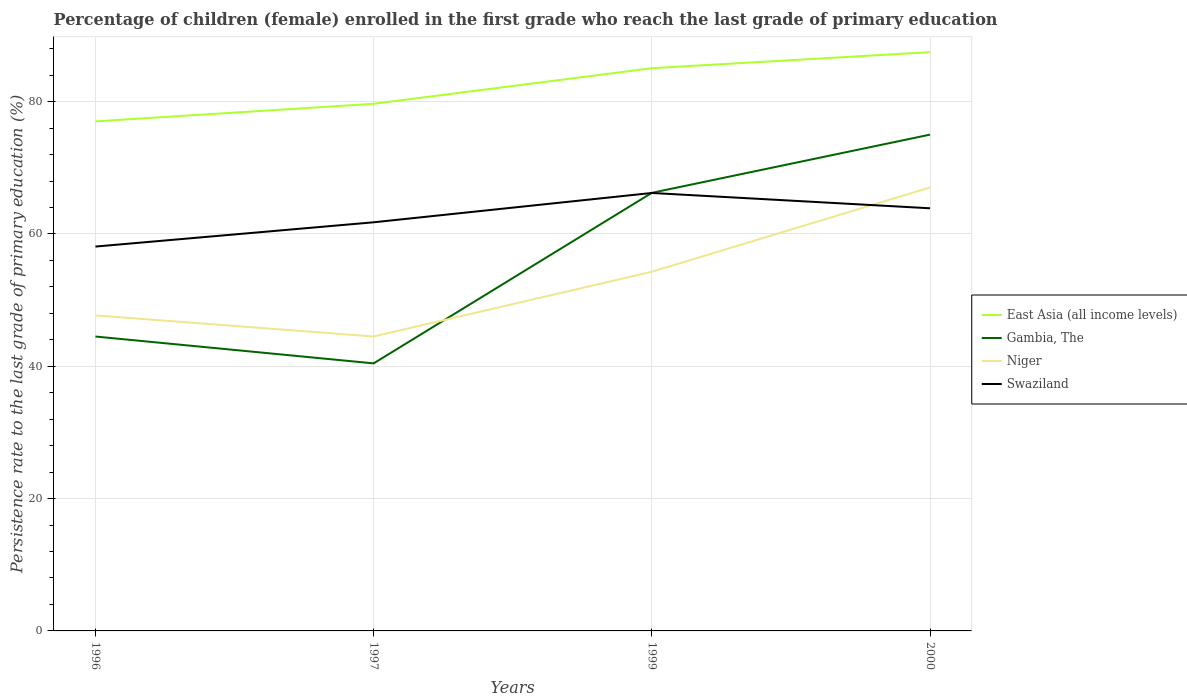Across all years, what is the maximum persistence rate of children in Niger?
Make the answer very short. 44.51. What is the total persistence rate of children in East Asia (all income levels) in the graph?
Offer a very short reply. -8.04. What is the difference between the highest and the second highest persistence rate of children in Gambia, The?
Your answer should be very brief. 34.57. What is the difference between the highest and the lowest persistence rate of children in Niger?
Provide a short and direct response. 2. Are the values on the major ticks of Y-axis written in scientific E-notation?
Give a very brief answer. No. Does the graph contain any zero values?
Your answer should be compact. No. How many legend labels are there?
Keep it short and to the point. 4. How are the legend labels stacked?
Give a very brief answer. Vertical. What is the title of the graph?
Your answer should be very brief. Percentage of children (female) enrolled in the first grade who reach the last grade of primary education. What is the label or title of the Y-axis?
Offer a very short reply. Persistence rate to the last grade of primary education (%). What is the Persistence rate to the last grade of primary education (%) in East Asia (all income levels) in 1996?
Your answer should be compact. 77.02. What is the Persistence rate to the last grade of primary education (%) of Gambia, The in 1996?
Your answer should be very brief. 44.5. What is the Persistence rate to the last grade of primary education (%) of Niger in 1996?
Your response must be concise. 47.69. What is the Persistence rate to the last grade of primary education (%) in Swaziland in 1996?
Keep it short and to the point. 58.1. What is the Persistence rate to the last grade of primary education (%) of East Asia (all income levels) in 1997?
Provide a succinct answer. 79.68. What is the Persistence rate to the last grade of primary education (%) of Gambia, The in 1997?
Offer a very short reply. 40.44. What is the Persistence rate to the last grade of primary education (%) in Niger in 1997?
Your response must be concise. 44.51. What is the Persistence rate to the last grade of primary education (%) of Swaziland in 1997?
Your response must be concise. 61.77. What is the Persistence rate to the last grade of primary education (%) in East Asia (all income levels) in 1999?
Your response must be concise. 85.05. What is the Persistence rate to the last grade of primary education (%) in Gambia, The in 1999?
Your answer should be very brief. 66.22. What is the Persistence rate to the last grade of primary education (%) of Niger in 1999?
Your answer should be compact. 54.29. What is the Persistence rate to the last grade of primary education (%) of Swaziland in 1999?
Provide a succinct answer. 66.2. What is the Persistence rate to the last grade of primary education (%) of East Asia (all income levels) in 2000?
Provide a short and direct response. 87.48. What is the Persistence rate to the last grade of primary education (%) of Gambia, The in 2000?
Offer a very short reply. 75.01. What is the Persistence rate to the last grade of primary education (%) in Niger in 2000?
Your answer should be very brief. 67.03. What is the Persistence rate to the last grade of primary education (%) in Swaziland in 2000?
Your answer should be very brief. 63.88. Across all years, what is the maximum Persistence rate to the last grade of primary education (%) in East Asia (all income levels)?
Your answer should be compact. 87.48. Across all years, what is the maximum Persistence rate to the last grade of primary education (%) in Gambia, The?
Keep it short and to the point. 75.01. Across all years, what is the maximum Persistence rate to the last grade of primary education (%) of Niger?
Your answer should be very brief. 67.03. Across all years, what is the maximum Persistence rate to the last grade of primary education (%) of Swaziland?
Provide a succinct answer. 66.2. Across all years, what is the minimum Persistence rate to the last grade of primary education (%) in East Asia (all income levels)?
Your answer should be compact. 77.02. Across all years, what is the minimum Persistence rate to the last grade of primary education (%) in Gambia, The?
Ensure brevity in your answer.  40.44. Across all years, what is the minimum Persistence rate to the last grade of primary education (%) of Niger?
Offer a very short reply. 44.51. Across all years, what is the minimum Persistence rate to the last grade of primary education (%) in Swaziland?
Ensure brevity in your answer.  58.1. What is the total Persistence rate to the last grade of primary education (%) of East Asia (all income levels) in the graph?
Provide a short and direct response. 329.23. What is the total Persistence rate to the last grade of primary education (%) in Gambia, The in the graph?
Make the answer very short. 226.17. What is the total Persistence rate to the last grade of primary education (%) of Niger in the graph?
Offer a very short reply. 213.52. What is the total Persistence rate to the last grade of primary education (%) in Swaziland in the graph?
Offer a terse response. 249.94. What is the difference between the Persistence rate to the last grade of primary education (%) of East Asia (all income levels) in 1996 and that in 1997?
Provide a succinct answer. -2.66. What is the difference between the Persistence rate to the last grade of primary education (%) of Gambia, The in 1996 and that in 1997?
Your answer should be compact. 4.06. What is the difference between the Persistence rate to the last grade of primary education (%) in Niger in 1996 and that in 1997?
Give a very brief answer. 3.19. What is the difference between the Persistence rate to the last grade of primary education (%) of Swaziland in 1996 and that in 1997?
Offer a terse response. -3.67. What is the difference between the Persistence rate to the last grade of primary education (%) in East Asia (all income levels) in 1996 and that in 1999?
Your response must be concise. -8.04. What is the difference between the Persistence rate to the last grade of primary education (%) of Gambia, The in 1996 and that in 1999?
Give a very brief answer. -21.72. What is the difference between the Persistence rate to the last grade of primary education (%) of Niger in 1996 and that in 1999?
Make the answer very short. -6.6. What is the difference between the Persistence rate to the last grade of primary education (%) of Swaziland in 1996 and that in 1999?
Your answer should be very brief. -8.1. What is the difference between the Persistence rate to the last grade of primary education (%) of East Asia (all income levels) in 1996 and that in 2000?
Offer a very short reply. -10.47. What is the difference between the Persistence rate to the last grade of primary education (%) in Gambia, The in 1996 and that in 2000?
Your response must be concise. -30.52. What is the difference between the Persistence rate to the last grade of primary education (%) in Niger in 1996 and that in 2000?
Provide a short and direct response. -19.34. What is the difference between the Persistence rate to the last grade of primary education (%) in Swaziland in 1996 and that in 2000?
Ensure brevity in your answer.  -5.79. What is the difference between the Persistence rate to the last grade of primary education (%) in East Asia (all income levels) in 1997 and that in 1999?
Make the answer very short. -5.38. What is the difference between the Persistence rate to the last grade of primary education (%) of Gambia, The in 1997 and that in 1999?
Give a very brief answer. -25.78. What is the difference between the Persistence rate to the last grade of primary education (%) of Niger in 1997 and that in 1999?
Your response must be concise. -9.79. What is the difference between the Persistence rate to the last grade of primary education (%) of Swaziland in 1997 and that in 1999?
Make the answer very short. -4.43. What is the difference between the Persistence rate to the last grade of primary education (%) in East Asia (all income levels) in 1997 and that in 2000?
Your response must be concise. -7.81. What is the difference between the Persistence rate to the last grade of primary education (%) of Gambia, The in 1997 and that in 2000?
Keep it short and to the point. -34.57. What is the difference between the Persistence rate to the last grade of primary education (%) of Niger in 1997 and that in 2000?
Keep it short and to the point. -22.53. What is the difference between the Persistence rate to the last grade of primary education (%) of Swaziland in 1997 and that in 2000?
Give a very brief answer. -2.12. What is the difference between the Persistence rate to the last grade of primary education (%) in East Asia (all income levels) in 1999 and that in 2000?
Give a very brief answer. -2.43. What is the difference between the Persistence rate to the last grade of primary education (%) of Gambia, The in 1999 and that in 2000?
Offer a terse response. -8.8. What is the difference between the Persistence rate to the last grade of primary education (%) in Niger in 1999 and that in 2000?
Your answer should be compact. -12.74. What is the difference between the Persistence rate to the last grade of primary education (%) in Swaziland in 1999 and that in 2000?
Offer a terse response. 2.31. What is the difference between the Persistence rate to the last grade of primary education (%) of East Asia (all income levels) in 1996 and the Persistence rate to the last grade of primary education (%) of Gambia, The in 1997?
Provide a short and direct response. 36.58. What is the difference between the Persistence rate to the last grade of primary education (%) in East Asia (all income levels) in 1996 and the Persistence rate to the last grade of primary education (%) in Niger in 1997?
Provide a short and direct response. 32.51. What is the difference between the Persistence rate to the last grade of primary education (%) of East Asia (all income levels) in 1996 and the Persistence rate to the last grade of primary education (%) of Swaziland in 1997?
Your answer should be compact. 15.25. What is the difference between the Persistence rate to the last grade of primary education (%) of Gambia, The in 1996 and the Persistence rate to the last grade of primary education (%) of Niger in 1997?
Offer a terse response. -0.01. What is the difference between the Persistence rate to the last grade of primary education (%) of Gambia, The in 1996 and the Persistence rate to the last grade of primary education (%) of Swaziland in 1997?
Make the answer very short. -17.27. What is the difference between the Persistence rate to the last grade of primary education (%) in Niger in 1996 and the Persistence rate to the last grade of primary education (%) in Swaziland in 1997?
Make the answer very short. -14.07. What is the difference between the Persistence rate to the last grade of primary education (%) in East Asia (all income levels) in 1996 and the Persistence rate to the last grade of primary education (%) in Gambia, The in 1999?
Keep it short and to the point. 10.8. What is the difference between the Persistence rate to the last grade of primary education (%) of East Asia (all income levels) in 1996 and the Persistence rate to the last grade of primary education (%) of Niger in 1999?
Ensure brevity in your answer.  22.73. What is the difference between the Persistence rate to the last grade of primary education (%) of East Asia (all income levels) in 1996 and the Persistence rate to the last grade of primary education (%) of Swaziland in 1999?
Provide a short and direct response. 10.82. What is the difference between the Persistence rate to the last grade of primary education (%) of Gambia, The in 1996 and the Persistence rate to the last grade of primary education (%) of Niger in 1999?
Provide a short and direct response. -9.79. What is the difference between the Persistence rate to the last grade of primary education (%) in Gambia, The in 1996 and the Persistence rate to the last grade of primary education (%) in Swaziland in 1999?
Your response must be concise. -21.7. What is the difference between the Persistence rate to the last grade of primary education (%) of Niger in 1996 and the Persistence rate to the last grade of primary education (%) of Swaziland in 1999?
Your response must be concise. -18.51. What is the difference between the Persistence rate to the last grade of primary education (%) of East Asia (all income levels) in 1996 and the Persistence rate to the last grade of primary education (%) of Gambia, The in 2000?
Your response must be concise. 2. What is the difference between the Persistence rate to the last grade of primary education (%) of East Asia (all income levels) in 1996 and the Persistence rate to the last grade of primary education (%) of Niger in 2000?
Offer a terse response. 9.98. What is the difference between the Persistence rate to the last grade of primary education (%) of East Asia (all income levels) in 1996 and the Persistence rate to the last grade of primary education (%) of Swaziland in 2000?
Keep it short and to the point. 13.14. What is the difference between the Persistence rate to the last grade of primary education (%) in Gambia, The in 1996 and the Persistence rate to the last grade of primary education (%) in Niger in 2000?
Offer a terse response. -22.53. What is the difference between the Persistence rate to the last grade of primary education (%) in Gambia, The in 1996 and the Persistence rate to the last grade of primary education (%) in Swaziland in 2000?
Give a very brief answer. -19.38. What is the difference between the Persistence rate to the last grade of primary education (%) of Niger in 1996 and the Persistence rate to the last grade of primary education (%) of Swaziland in 2000?
Offer a terse response. -16.19. What is the difference between the Persistence rate to the last grade of primary education (%) in East Asia (all income levels) in 1997 and the Persistence rate to the last grade of primary education (%) in Gambia, The in 1999?
Give a very brief answer. 13.46. What is the difference between the Persistence rate to the last grade of primary education (%) in East Asia (all income levels) in 1997 and the Persistence rate to the last grade of primary education (%) in Niger in 1999?
Your answer should be compact. 25.38. What is the difference between the Persistence rate to the last grade of primary education (%) of East Asia (all income levels) in 1997 and the Persistence rate to the last grade of primary education (%) of Swaziland in 1999?
Provide a short and direct response. 13.48. What is the difference between the Persistence rate to the last grade of primary education (%) in Gambia, The in 1997 and the Persistence rate to the last grade of primary education (%) in Niger in 1999?
Give a very brief answer. -13.85. What is the difference between the Persistence rate to the last grade of primary education (%) in Gambia, The in 1997 and the Persistence rate to the last grade of primary education (%) in Swaziland in 1999?
Give a very brief answer. -25.76. What is the difference between the Persistence rate to the last grade of primary education (%) of Niger in 1997 and the Persistence rate to the last grade of primary education (%) of Swaziland in 1999?
Keep it short and to the point. -21.69. What is the difference between the Persistence rate to the last grade of primary education (%) of East Asia (all income levels) in 1997 and the Persistence rate to the last grade of primary education (%) of Gambia, The in 2000?
Provide a succinct answer. 4.66. What is the difference between the Persistence rate to the last grade of primary education (%) in East Asia (all income levels) in 1997 and the Persistence rate to the last grade of primary education (%) in Niger in 2000?
Offer a terse response. 12.64. What is the difference between the Persistence rate to the last grade of primary education (%) in East Asia (all income levels) in 1997 and the Persistence rate to the last grade of primary education (%) in Swaziland in 2000?
Your answer should be very brief. 15.79. What is the difference between the Persistence rate to the last grade of primary education (%) of Gambia, The in 1997 and the Persistence rate to the last grade of primary education (%) of Niger in 2000?
Provide a succinct answer. -26.59. What is the difference between the Persistence rate to the last grade of primary education (%) in Gambia, The in 1997 and the Persistence rate to the last grade of primary education (%) in Swaziland in 2000?
Make the answer very short. -23.44. What is the difference between the Persistence rate to the last grade of primary education (%) of Niger in 1997 and the Persistence rate to the last grade of primary education (%) of Swaziland in 2000?
Provide a succinct answer. -19.38. What is the difference between the Persistence rate to the last grade of primary education (%) of East Asia (all income levels) in 1999 and the Persistence rate to the last grade of primary education (%) of Gambia, The in 2000?
Keep it short and to the point. 10.04. What is the difference between the Persistence rate to the last grade of primary education (%) of East Asia (all income levels) in 1999 and the Persistence rate to the last grade of primary education (%) of Niger in 2000?
Offer a terse response. 18.02. What is the difference between the Persistence rate to the last grade of primary education (%) of East Asia (all income levels) in 1999 and the Persistence rate to the last grade of primary education (%) of Swaziland in 2000?
Your response must be concise. 21.17. What is the difference between the Persistence rate to the last grade of primary education (%) of Gambia, The in 1999 and the Persistence rate to the last grade of primary education (%) of Niger in 2000?
Offer a terse response. -0.81. What is the difference between the Persistence rate to the last grade of primary education (%) in Gambia, The in 1999 and the Persistence rate to the last grade of primary education (%) in Swaziland in 2000?
Offer a very short reply. 2.34. What is the difference between the Persistence rate to the last grade of primary education (%) in Niger in 1999 and the Persistence rate to the last grade of primary education (%) in Swaziland in 2000?
Provide a succinct answer. -9.59. What is the average Persistence rate to the last grade of primary education (%) in East Asia (all income levels) per year?
Give a very brief answer. 82.31. What is the average Persistence rate to the last grade of primary education (%) of Gambia, The per year?
Offer a very short reply. 56.54. What is the average Persistence rate to the last grade of primary education (%) of Niger per year?
Your answer should be very brief. 53.38. What is the average Persistence rate to the last grade of primary education (%) in Swaziland per year?
Offer a very short reply. 62.48. In the year 1996, what is the difference between the Persistence rate to the last grade of primary education (%) of East Asia (all income levels) and Persistence rate to the last grade of primary education (%) of Gambia, The?
Provide a short and direct response. 32.52. In the year 1996, what is the difference between the Persistence rate to the last grade of primary education (%) of East Asia (all income levels) and Persistence rate to the last grade of primary education (%) of Niger?
Ensure brevity in your answer.  29.33. In the year 1996, what is the difference between the Persistence rate to the last grade of primary education (%) in East Asia (all income levels) and Persistence rate to the last grade of primary education (%) in Swaziland?
Offer a terse response. 18.92. In the year 1996, what is the difference between the Persistence rate to the last grade of primary education (%) of Gambia, The and Persistence rate to the last grade of primary education (%) of Niger?
Provide a succinct answer. -3.19. In the year 1996, what is the difference between the Persistence rate to the last grade of primary education (%) in Gambia, The and Persistence rate to the last grade of primary education (%) in Swaziland?
Offer a very short reply. -13.6. In the year 1996, what is the difference between the Persistence rate to the last grade of primary education (%) of Niger and Persistence rate to the last grade of primary education (%) of Swaziland?
Give a very brief answer. -10.41. In the year 1997, what is the difference between the Persistence rate to the last grade of primary education (%) in East Asia (all income levels) and Persistence rate to the last grade of primary education (%) in Gambia, The?
Ensure brevity in your answer.  39.24. In the year 1997, what is the difference between the Persistence rate to the last grade of primary education (%) in East Asia (all income levels) and Persistence rate to the last grade of primary education (%) in Niger?
Offer a terse response. 35.17. In the year 1997, what is the difference between the Persistence rate to the last grade of primary education (%) in East Asia (all income levels) and Persistence rate to the last grade of primary education (%) in Swaziland?
Make the answer very short. 17.91. In the year 1997, what is the difference between the Persistence rate to the last grade of primary education (%) in Gambia, The and Persistence rate to the last grade of primary education (%) in Niger?
Ensure brevity in your answer.  -4.07. In the year 1997, what is the difference between the Persistence rate to the last grade of primary education (%) in Gambia, The and Persistence rate to the last grade of primary education (%) in Swaziland?
Make the answer very short. -21.33. In the year 1997, what is the difference between the Persistence rate to the last grade of primary education (%) in Niger and Persistence rate to the last grade of primary education (%) in Swaziland?
Provide a short and direct response. -17.26. In the year 1999, what is the difference between the Persistence rate to the last grade of primary education (%) in East Asia (all income levels) and Persistence rate to the last grade of primary education (%) in Gambia, The?
Give a very brief answer. 18.84. In the year 1999, what is the difference between the Persistence rate to the last grade of primary education (%) in East Asia (all income levels) and Persistence rate to the last grade of primary education (%) in Niger?
Provide a short and direct response. 30.76. In the year 1999, what is the difference between the Persistence rate to the last grade of primary education (%) of East Asia (all income levels) and Persistence rate to the last grade of primary education (%) of Swaziland?
Keep it short and to the point. 18.86. In the year 1999, what is the difference between the Persistence rate to the last grade of primary education (%) of Gambia, The and Persistence rate to the last grade of primary education (%) of Niger?
Ensure brevity in your answer.  11.93. In the year 1999, what is the difference between the Persistence rate to the last grade of primary education (%) of Gambia, The and Persistence rate to the last grade of primary education (%) of Swaziland?
Ensure brevity in your answer.  0.02. In the year 1999, what is the difference between the Persistence rate to the last grade of primary education (%) of Niger and Persistence rate to the last grade of primary education (%) of Swaziland?
Offer a very short reply. -11.9. In the year 2000, what is the difference between the Persistence rate to the last grade of primary education (%) of East Asia (all income levels) and Persistence rate to the last grade of primary education (%) of Gambia, The?
Keep it short and to the point. 12.47. In the year 2000, what is the difference between the Persistence rate to the last grade of primary education (%) of East Asia (all income levels) and Persistence rate to the last grade of primary education (%) of Niger?
Your answer should be compact. 20.45. In the year 2000, what is the difference between the Persistence rate to the last grade of primary education (%) of East Asia (all income levels) and Persistence rate to the last grade of primary education (%) of Swaziland?
Your answer should be very brief. 23.6. In the year 2000, what is the difference between the Persistence rate to the last grade of primary education (%) in Gambia, The and Persistence rate to the last grade of primary education (%) in Niger?
Give a very brief answer. 7.98. In the year 2000, what is the difference between the Persistence rate to the last grade of primary education (%) in Gambia, The and Persistence rate to the last grade of primary education (%) in Swaziland?
Provide a short and direct response. 11.13. In the year 2000, what is the difference between the Persistence rate to the last grade of primary education (%) in Niger and Persistence rate to the last grade of primary education (%) in Swaziland?
Give a very brief answer. 3.15. What is the ratio of the Persistence rate to the last grade of primary education (%) of East Asia (all income levels) in 1996 to that in 1997?
Provide a succinct answer. 0.97. What is the ratio of the Persistence rate to the last grade of primary education (%) in Gambia, The in 1996 to that in 1997?
Your answer should be very brief. 1.1. What is the ratio of the Persistence rate to the last grade of primary education (%) of Niger in 1996 to that in 1997?
Ensure brevity in your answer.  1.07. What is the ratio of the Persistence rate to the last grade of primary education (%) of Swaziland in 1996 to that in 1997?
Your answer should be very brief. 0.94. What is the ratio of the Persistence rate to the last grade of primary education (%) of East Asia (all income levels) in 1996 to that in 1999?
Keep it short and to the point. 0.91. What is the ratio of the Persistence rate to the last grade of primary education (%) of Gambia, The in 1996 to that in 1999?
Your response must be concise. 0.67. What is the ratio of the Persistence rate to the last grade of primary education (%) in Niger in 1996 to that in 1999?
Give a very brief answer. 0.88. What is the ratio of the Persistence rate to the last grade of primary education (%) of Swaziland in 1996 to that in 1999?
Make the answer very short. 0.88. What is the ratio of the Persistence rate to the last grade of primary education (%) of East Asia (all income levels) in 1996 to that in 2000?
Offer a very short reply. 0.88. What is the ratio of the Persistence rate to the last grade of primary education (%) of Gambia, The in 1996 to that in 2000?
Ensure brevity in your answer.  0.59. What is the ratio of the Persistence rate to the last grade of primary education (%) in Niger in 1996 to that in 2000?
Make the answer very short. 0.71. What is the ratio of the Persistence rate to the last grade of primary education (%) in Swaziland in 1996 to that in 2000?
Offer a terse response. 0.91. What is the ratio of the Persistence rate to the last grade of primary education (%) in East Asia (all income levels) in 1997 to that in 1999?
Make the answer very short. 0.94. What is the ratio of the Persistence rate to the last grade of primary education (%) of Gambia, The in 1997 to that in 1999?
Provide a succinct answer. 0.61. What is the ratio of the Persistence rate to the last grade of primary education (%) in Niger in 1997 to that in 1999?
Your answer should be compact. 0.82. What is the ratio of the Persistence rate to the last grade of primary education (%) in Swaziland in 1997 to that in 1999?
Provide a short and direct response. 0.93. What is the ratio of the Persistence rate to the last grade of primary education (%) in East Asia (all income levels) in 1997 to that in 2000?
Ensure brevity in your answer.  0.91. What is the ratio of the Persistence rate to the last grade of primary education (%) in Gambia, The in 1997 to that in 2000?
Keep it short and to the point. 0.54. What is the ratio of the Persistence rate to the last grade of primary education (%) of Niger in 1997 to that in 2000?
Make the answer very short. 0.66. What is the ratio of the Persistence rate to the last grade of primary education (%) in Swaziland in 1997 to that in 2000?
Your answer should be very brief. 0.97. What is the ratio of the Persistence rate to the last grade of primary education (%) of East Asia (all income levels) in 1999 to that in 2000?
Provide a succinct answer. 0.97. What is the ratio of the Persistence rate to the last grade of primary education (%) in Gambia, The in 1999 to that in 2000?
Provide a succinct answer. 0.88. What is the ratio of the Persistence rate to the last grade of primary education (%) of Niger in 1999 to that in 2000?
Your response must be concise. 0.81. What is the ratio of the Persistence rate to the last grade of primary education (%) of Swaziland in 1999 to that in 2000?
Your response must be concise. 1.04. What is the difference between the highest and the second highest Persistence rate to the last grade of primary education (%) in East Asia (all income levels)?
Provide a succinct answer. 2.43. What is the difference between the highest and the second highest Persistence rate to the last grade of primary education (%) of Gambia, The?
Provide a short and direct response. 8.8. What is the difference between the highest and the second highest Persistence rate to the last grade of primary education (%) in Niger?
Your answer should be very brief. 12.74. What is the difference between the highest and the second highest Persistence rate to the last grade of primary education (%) of Swaziland?
Make the answer very short. 2.31. What is the difference between the highest and the lowest Persistence rate to the last grade of primary education (%) of East Asia (all income levels)?
Give a very brief answer. 10.47. What is the difference between the highest and the lowest Persistence rate to the last grade of primary education (%) of Gambia, The?
Make the answer very short. 34.57. What is the difference between the highest and the lowest Persistence rate to the last grade of primary education (%) in Niger?
Your answer should be compact. 22.53. What is the difference between the highest and the lowest Persistence rate to the last grade of primary education (%) in Swaziland?
Offer a very short reply. 8.1. 